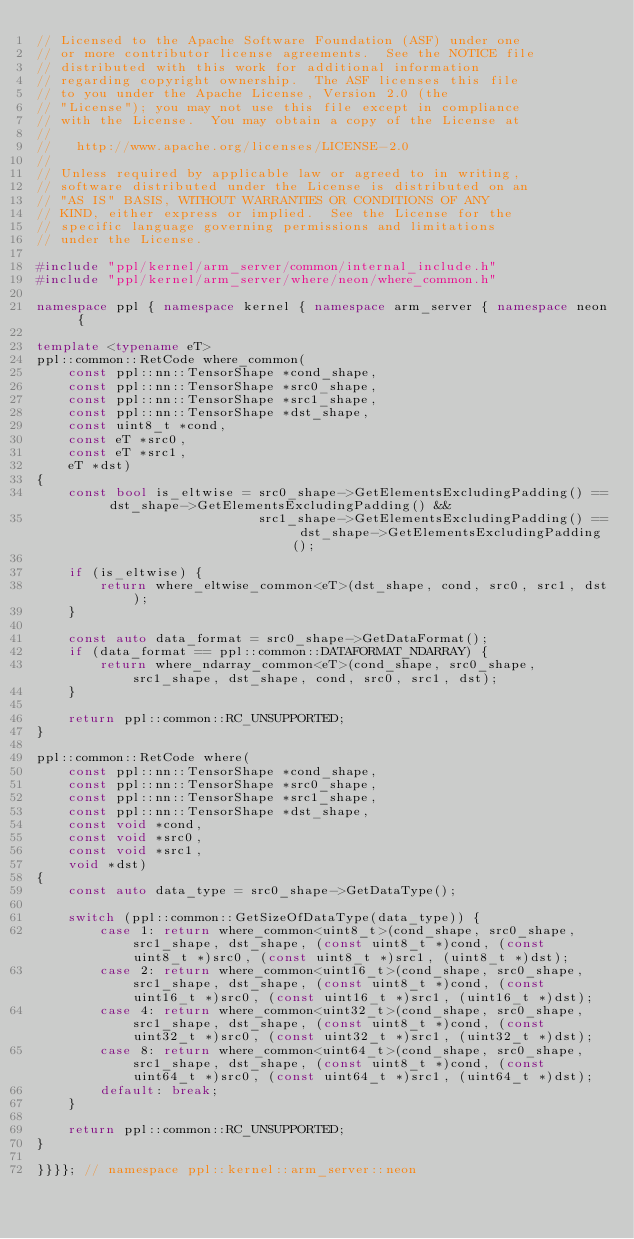Convert code to text. <code><loc_0><loc_0><loc_500><loc_500><_C++_>// Licensed to the Apache Software Foundation (ASF) under one
// or more contributor license agreements.  See the NOTICE file
// distributed with this work for additional information
// regarding copyright ownership.  The ASF licenses this file
// to you under the Apache License, Version 2.0 (the
// "License"); you may not use this file except in compliance
// with the License.  You may obtain a copy of the License at
//
//   http://www.apache.org/licenses/LICENSE-2.0
//
// Unless required by applicable law or agreed to in writing,
// software distributed under the License is distributed on an
// "AS IS" BASIS, WITHOUT WARRANTIES OR CONDITIONS OF ANY
// KIND, either express or implied.  See the License for the
// specific language governing permissions and limitations
// under the License.

#include "ppl/kernel/arm_server/common/internal_include.h"
#include "ppl/kernel/arm_server/where/neon/where_common.h"

namespace ppl { namespace kernel { namespace arm_server { namespace neon {

template <typename eT>
ppl::common::RetCode where_common(
    const ppl::nn::TensorShape *cond_shape,
    const ppl::nn::TensorShape *src0_shape,
    const ppl::nn::TensorShape *src1_shape,
    const ppl::nn::TensorShape *dst_shape,
    const uint8_t *cond,
    const eT *src0,
    const eT *src1,
    eT *dst)
{
    const bool is_eltwise = src0_shape->GetElementsExcludingPadding() == dst_shape->GetElementsExcludingPadding() &&
                            src1_shape->GetElementsExcludingPadding() == dst_shape->GetElementsExcludingPadding();

    if (is_eltwise) {
        return where_eltwise_common<eT>(dst_shape, cond, src0, src1, dst);
    }

    const auto data_format = src0_shape->GetDataFormat();
    if (data_format == ppl::common::DATAFORMAT_NDARRAY) {
        return where_ndarray_common<eT>(cond_shape, src0_shape, src1_shape, dst_shape, cond, src0, src1, dst);
    }

    return ppl::common::RC_UNSUPPORTED;
}

ppl::common::RetCode where(
    const ppl::nn::TensorShape *cond_shape,
    const ppl::nn::TensorShape *src0_shape,
    const ppl::nn::TensorShape *src1_shape,
    const ppl::nn::TensorShape *dst_shape,
    const void *cond,
    const void *src0,
    const void *src1,
    void *dst)
{
    const auto data_type = src0_shape->GetDataType();

    switch (ppl::common::GetSizeOfDataType(data_type)) {
        case 1: return where_common<uint8_t>(cond_shape, src0_shape, src1_shape, dst_shape, (const uint8_t *)cond, (const uint8_t *)src0, (const uint8_t *)src1, (uint8_t *)dst);
        case 2: return where_common<uint16_t>(cond_shape, src0_shape, src1_shape, dst_shape, (const uint8_t *)cond, (const uint16_t *)src0, (const uint16_t *)src1, (uint16_t *)dst);
        case 4: return where_common<uint32_t>(cond_shape, src0_shape, src1_shape, dst_shape, (const uint8_t *)cond, (const uint32_t *)src0, (const uint32_t *)src1, (uint32_t *)dst);
        case 8: return where_common<uint64_t>(cond_shape, src0_shape, src1_shape, dst_shape, (const uint8_t *)cond, (const uint64_t *)src0, (const uint64_t *)src1, (uint64_t *)dst);
        default: break;
    }

    return ppl::common::RC_UNSUPPORTED;
}

}}}}; // namespace ppl::kernel::arm_server::neon
</code> 